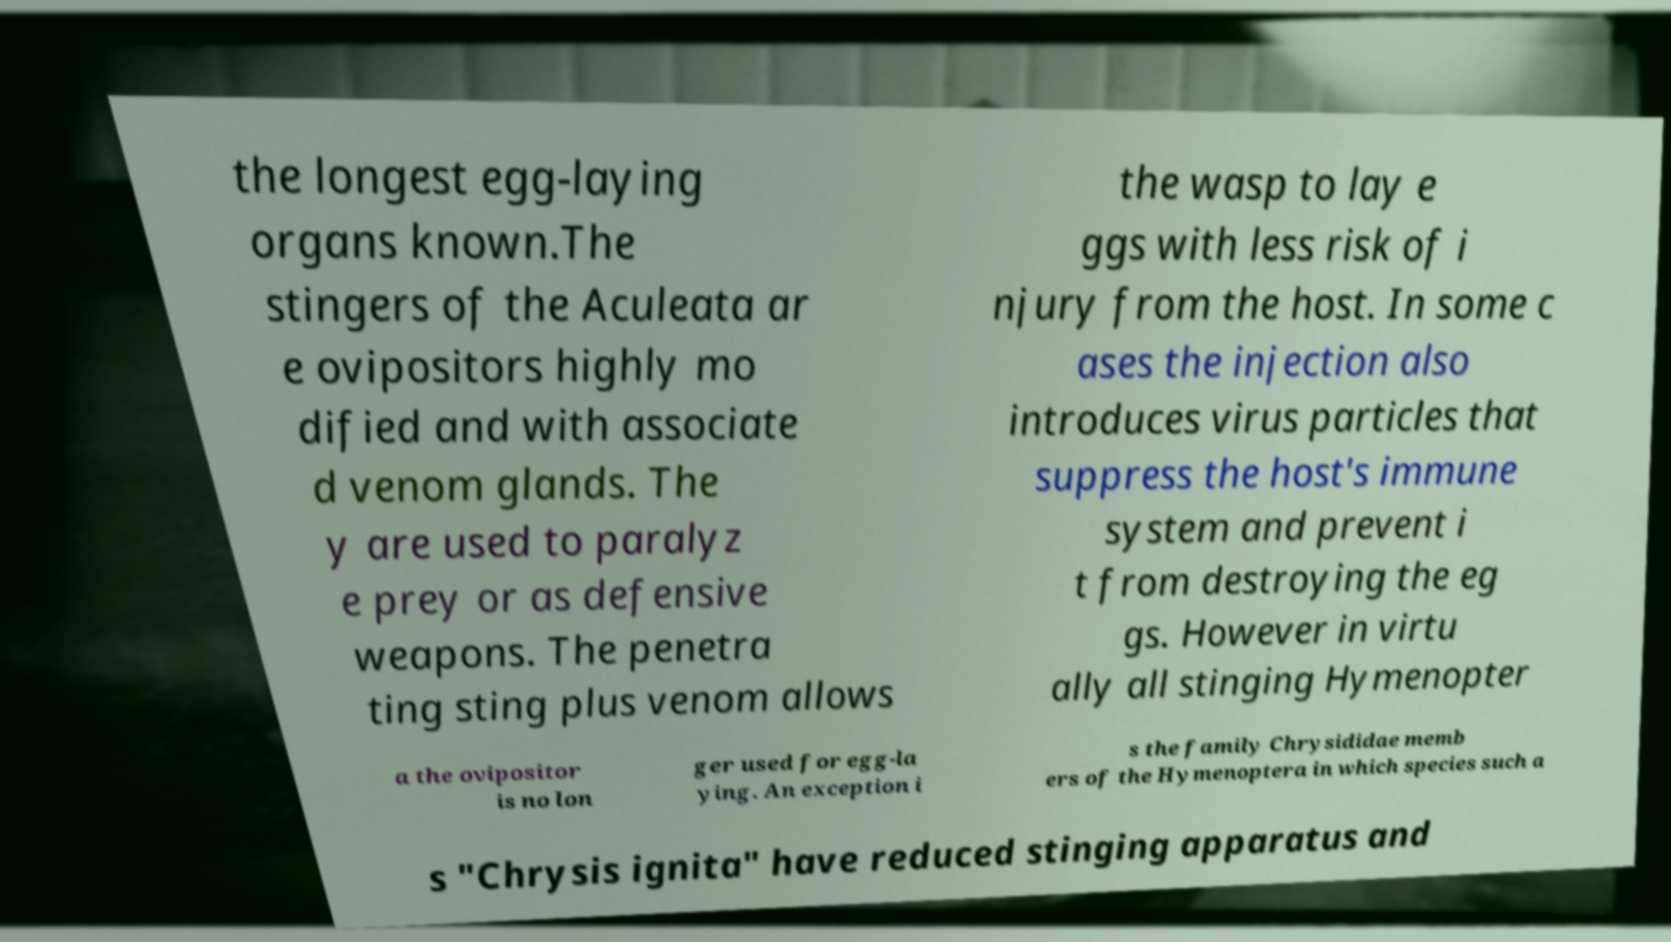Can you accurately transcribe the text from the provided image for me? the longest egg-laying organs known.The stingers of the Aculeata ar e ovipositors highly mo dified and with associate d venom glands. The y are used to paralyz e prey or as defensive weapons. The penetra ting sting plus venom allows the wasp to lay e ggs with less risk of i njury from the host. In some c ases the injection also introduces virus particles that suppress the host's immune system and prevent i t from destroying the eg gs. However in virtu ally all stinging Hymenopter a the ovipositor is no lon ger used for egg-la ying. An exception i s the family Chrysididae memb ers of the Hymenoptera in which species such a s "Chrysis ignita" have reduced stinging apparatus and 